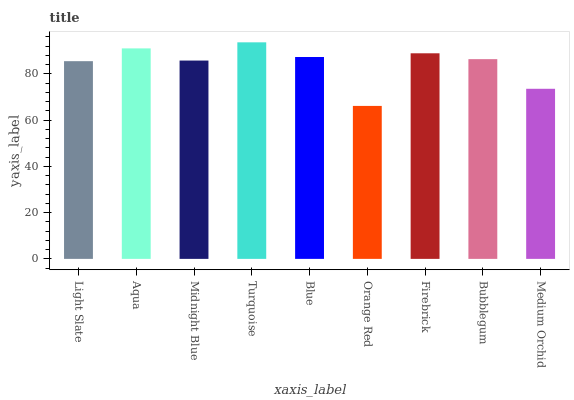Is Orange Red the minimum?
Answer yes or no. Yes. Is Turquoise the maximum?
Answer yes or no. Yes. Is Aqua the minimum?
Answer yes or no. No. Is Aqua the maximum?
Answer yes or no. No. Is Aqua greater than Light Slate?
Answer yes or no. Yes. Is Light Slate less than Aqua?
Answer yes or no. Yes. Is Light Slate greater than Aqua?
Answer yes or no. No. Is Aqua less than Light Slate?
Answer yes or no. No. Is Bubblegum the high median?
Answer yes or no. Yes. Is Bubblegum the low median?
Answer yes or no. Yes. Is Light Slate the high median?
Answer yes or no. No. Is Turquoise the low median?
Answer yes or no. No. 